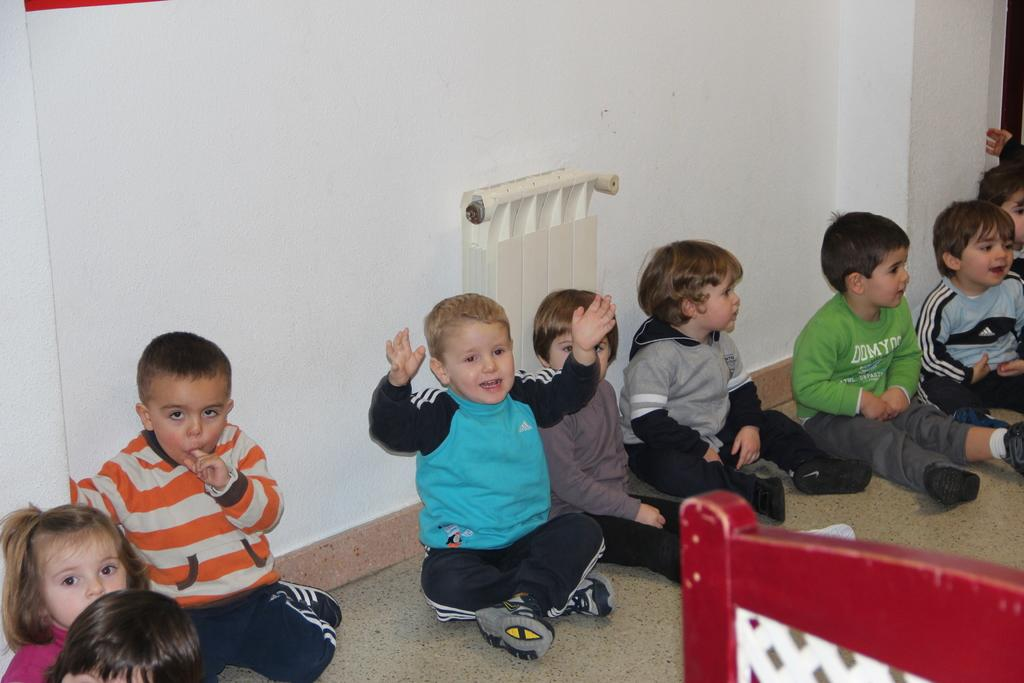What object can be found in the bottom right corner of the image? There is a chair in the bottom right corner of the image. What are the kids in the middle of the image doing? The kids are sitting and smiling in the middle of the image. What is behind the kids in the image? There is a wall behind the kids. Can you see a fireman putting out a bomb in the image? No, there is no fireman or bomb present in the image. Is there snow covering the ground in the image? No, there is no snow visible in the image. 